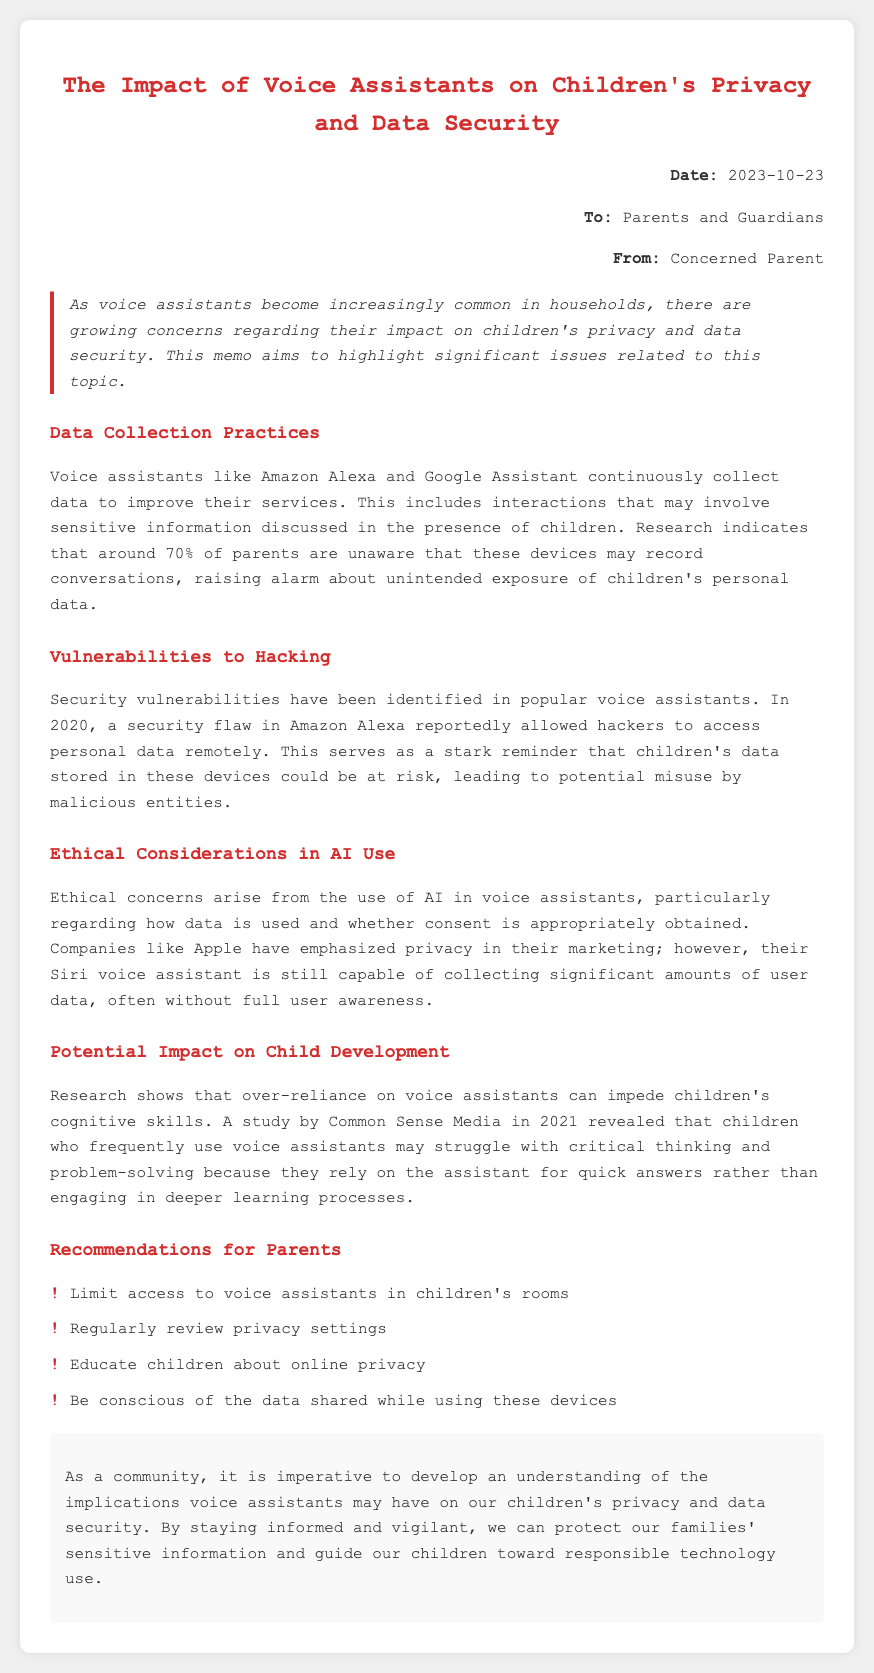What is the date of the memo? The date is explicitly stated in the header section of the memo.
Answer: 2023-10-23 Who is the memo addressed to? The memo mentions the audience directly in the address section.
Answer: Parents and Guardians What percentage of parents are unaware of recording features? The document provides a specific statistic regarding parent awareness.
Answer: 70% What was identified in 2020 regarding Amazon Alexa? The memo describes a specific security issue related to Amazon Alexa.
Answer: A security flaw Which company emphasizes privacy in their marketing? The memo highlights a company that markets itself on privacy yet has capabilities that concern data collection.
Answer: Apple What does the study by Common Sense Media in 2021 indicate? The document mentions findings from this study related to child development and technology use.
Answer: Over-reliance impedes cognitive skills What is one recommendation for parents regarding voice assistants? The list offers actionable advice for parents in managing voice assistants.
Answer: Limit access to voice assistants in children's rooms What is the main concern of this memo? The introductory section outlines the core topic discussed throughout the document.
Answer: Children's privacy and data security 